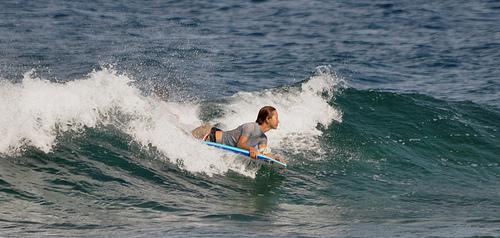Question: what color is the water?
Choices:
A. Clear.
B. Blueish/Green.
C. Brown.
D. Red.
Answer with the letter. Answer: B Question: why is she holding on?
Choices:
A. To pose for a photo.
B. Someone is telling her to.
C. She doesn't fall off.
D. She is demonstrating for someone else.
Answer with the letter. Answer: C Question: where is she surfing?
Choices:
A. In a lake.
B. In a wave pool.
C. In the Ocean.
D. In a video simulation.
Answer with the letter. Answer: C Question: who is surfing?
Choices:
A. A man.
B. A couple.
C. A boy with his dog.
D. A girl.
Answer with the letter. Answer: D 